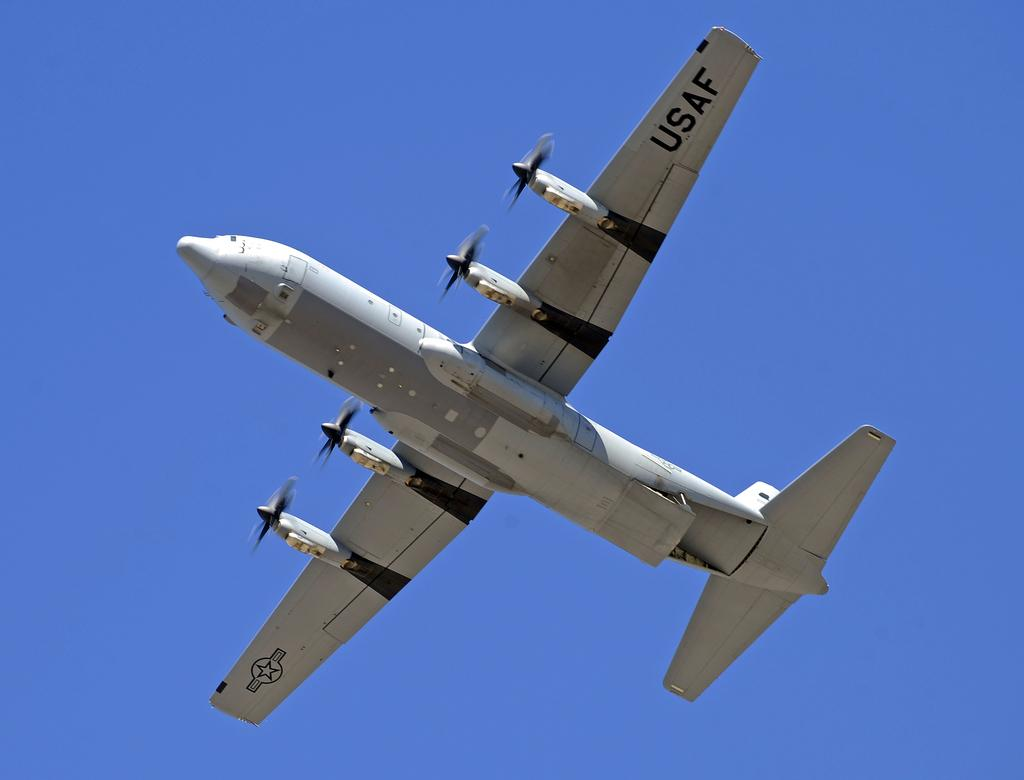Provide a one-sentence caption for the provided image. the USAF plane is flying through the clear blue sky. 